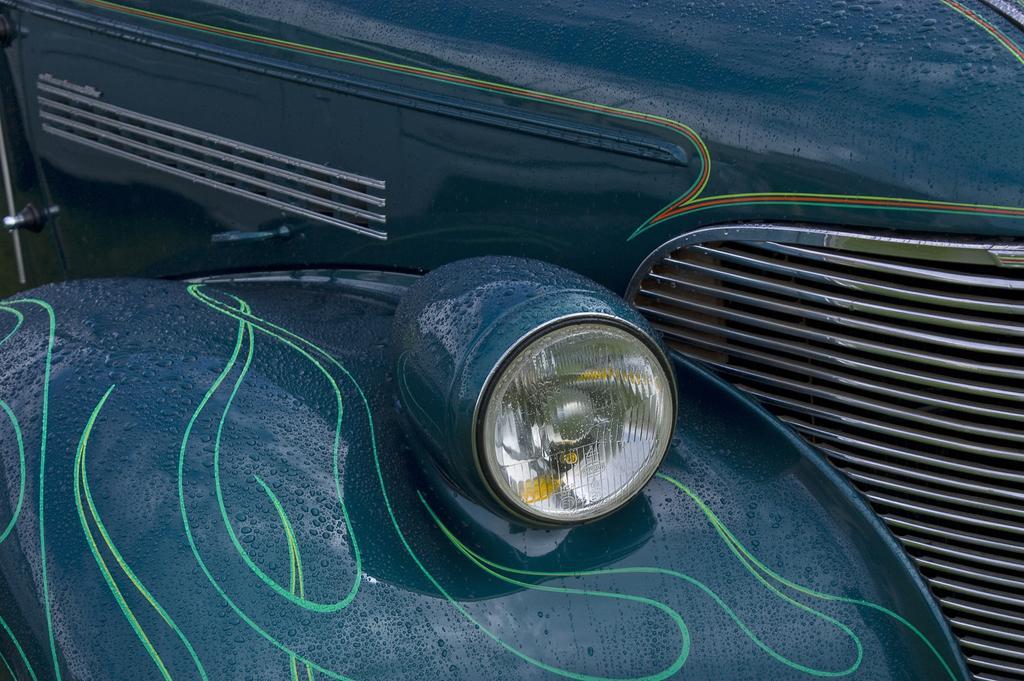Can you describe this image briefly? In this image we can see a headlight of a car. 